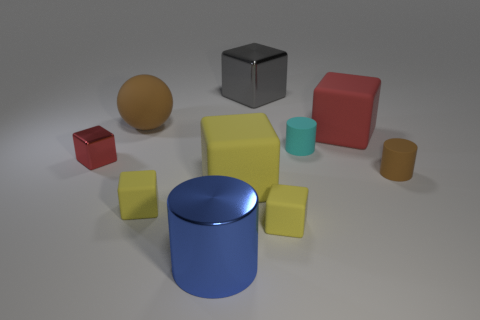There is a big cube that is the same color as the tiny metal thing; what material is it?
Ensure brevity in your answer.  Rubber. How many things are big things on the left side of the gray cube or tiny yellow objects that are right of the blue object?
Ensure brevity in your answer.  4. Is the size of the brown rubber object behind the small brown thing the same as the matte cylinder behind the brown cylinder?
Offer a very short reply. No. Are there any big brown objects on the right side of the red object to the left of the big blue metallic object?
Provide a short and direct response. Yes. What number of big metallic cylinders are right of the brown matte sphere?
Provide a succinct answer. 1. What number of other objects are the same color as the small shiny thing?
Keep it short and to the point. 1. Is the number of large metal cubes that are in front of the big brown sphere less than the number of brown rubber cylinders in front of the tiny shiny object?
Ensure brevity in your answer.  Yes. What number of objects are brown rubber objects that are right of the small cyan cylinder or small brown objects?
Keep it short and to the point. 1. Does the blue shiny cylinder have the same size as the matte cylinder to the left of the tiny brown matte cylinder?
Your answer should be very brief. No. There is another shiny thing that is the same shape as the large gray metallic thing; what size is it?
Provide a succinct answer. Small. 